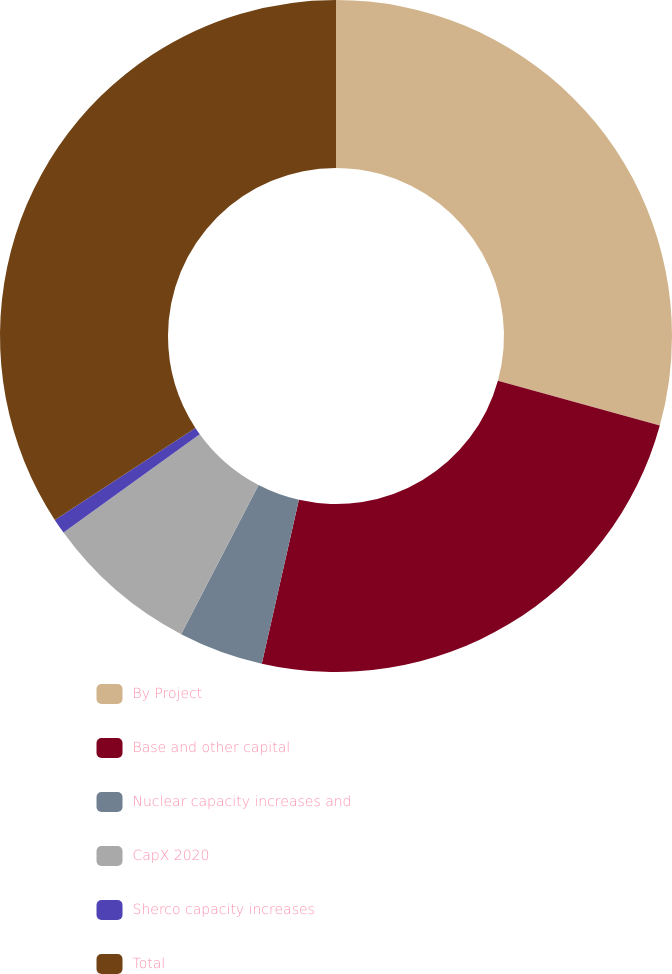<chart> <loc_0><loc_0><loc_500><loc_500><pie_chart><fcel>By Project<fcel>Base and other capital<fcel>Nuclear capacity increases and<fcel>CapX 2020<fcel>Sherco capacity increases<fcel>Total<nl><fcel>29.3%<fcel>24.25%<fcel>4.08%<fcel>7.43%<fcel>0.73%<fcel>34.22%<nl></chart> 